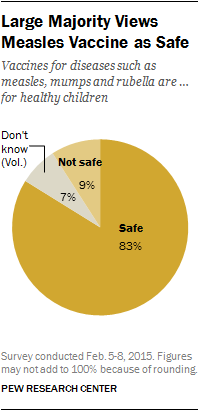Identify some key points in this picture. The total value of the smallest and largest segments of the graph is 90. The color of the "Don't Know" segment of the graph is gray. 